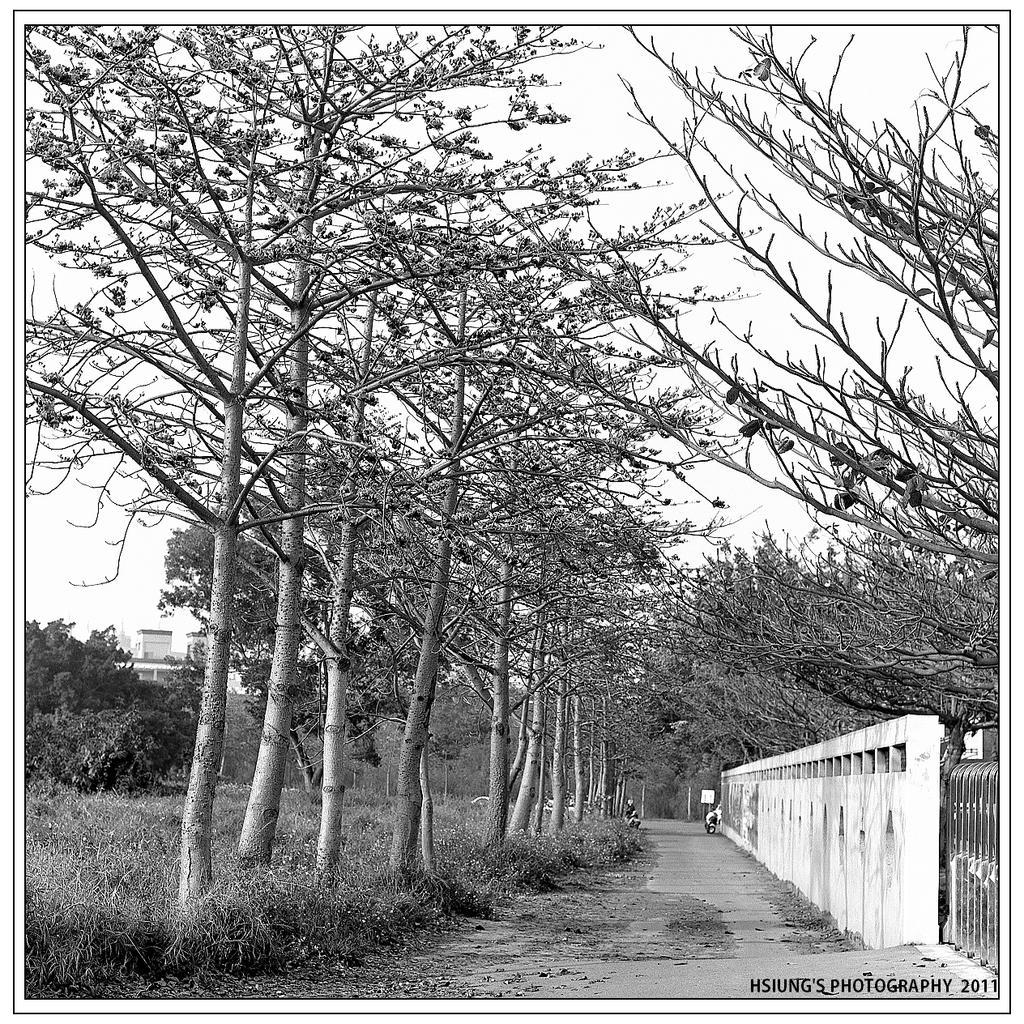Can you describe this image briefly? This is a black and white image. In this image we can see trees. Also there are plants. On the right side there is a wall. In the background there is sky. Also there are buildings. In the right bottom corner there is text. 